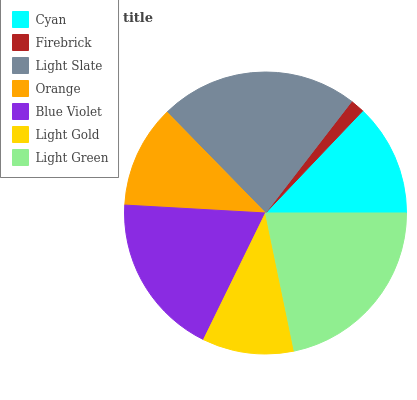Is Firebrick the minimum?
Answer yes or no. Yes. Is Light Slate the maximum?
Answer yes or no. Yes. Is Light Slate the minimum?
Answer yes or no. No. Is Firebrick the maximum?
Answer yes or no. No. Is Light Slate greater than Firebrick?
Answer yes or no. Yes. Is Firebrick less than Light Slate?
Answer yes or no. Yes. Is Firebrick greater than Light Slate?
Answer yes or no. No. Is Light Slate less than Firebrick?
Answer yes or no. No. Is Cyan the high median?
Answer yes or no. Yes. Is Cyan the low median?
Answer yes or no. Yes. Is Light Green the high median?
Answer yes or no. No. Is Blue Violet the low median?
Answer yes or no. No. 